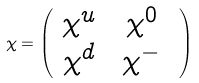Convert formula to latex. <formula><loc_0><loc_0><loc_500><loc_500>\chi = \left ( \begin{array} { c c } \chi ^ { u } \ & \chi ^ { 0 } \ \\ \chi ^ { d } \ & \chi ^ { - } \ \end{array} \right )</formula> 